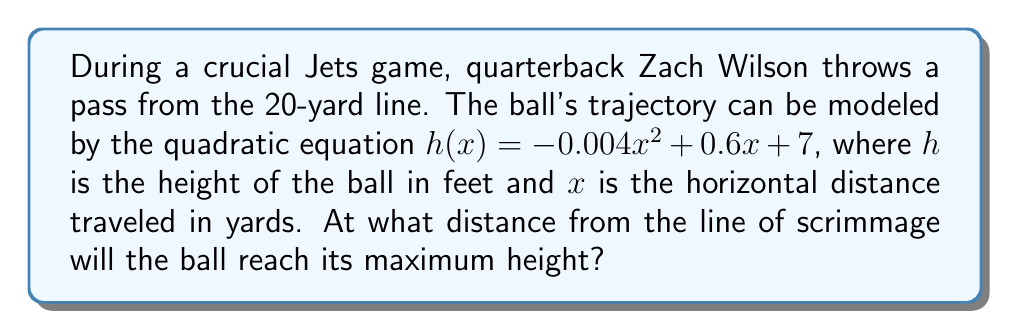Show me your answer to this math problem. To find the distance at which the ball reaches its maximum height, we need to follow these steps:

1) The quadratic equation given is:
   $h(x) = -0.004x^2 + 0.6x + 7$

2) For a quadratic equation in the form $f(x) = ax^2 + bx + c$, the x-coordinate of the vertex (which represents the maximum or minimum point) is given by the formula:

   $x = -\frac{b}{2a}$

3) In our equation:
   $a = -0.004$
   $b = 0.6$

4) Substituting these values into the formula:

   $x = -\frac{0.6}{2(-0.004)} = -\frac{0.6}{-0.008} = 75$

5) Therefore, the ball will reach its maximum height 75 yards from the line of scrimmage.

6) To verify, we can calculate the height at 74, 75, and 76 yards:

   $h(74) = -0.004(74)^2 + 0.6(74) + 7 = 29.184$ feet
   $h(75) = -0.004(75)^2 + 0.6(75) + 7 = 29.25$ feet
   $h(76) = -0.004(76)^2 + 0.6(76) + 7 = 29.184$ feet

   This confirms that the maximum height occurs at 75 yards.
Answer: 75 yards 